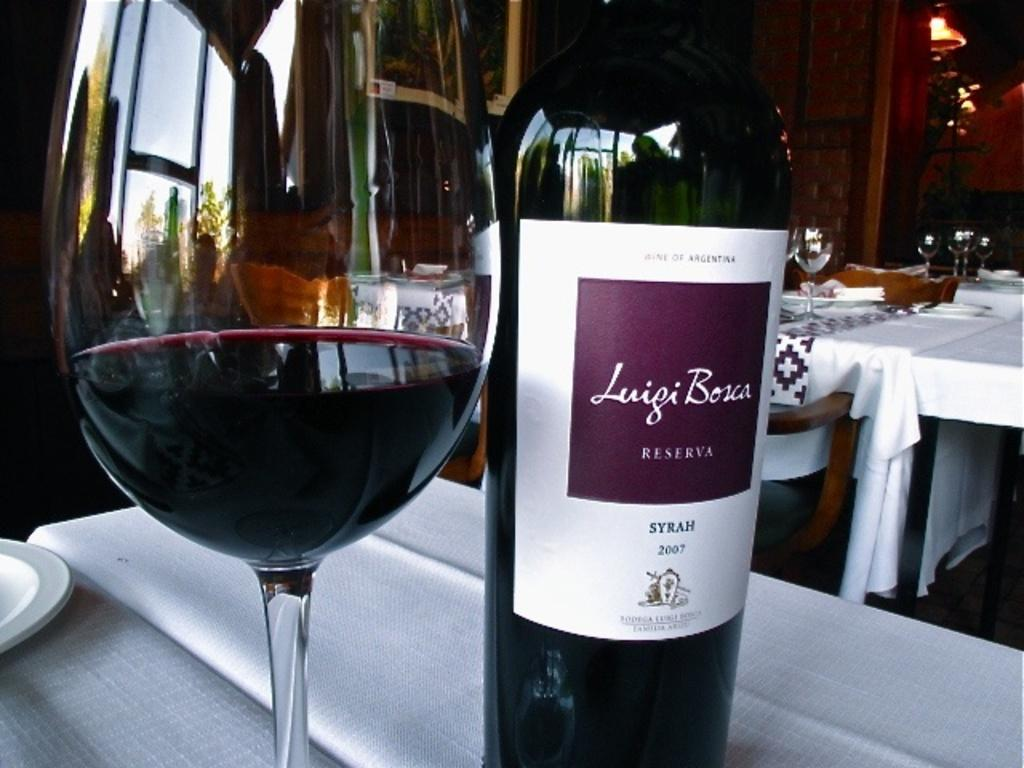<image>
Relay a brief, clear account of the picture shown. A wine glass sitting next to a bottle of Luigi Bosca Reserva 2007 wine. 